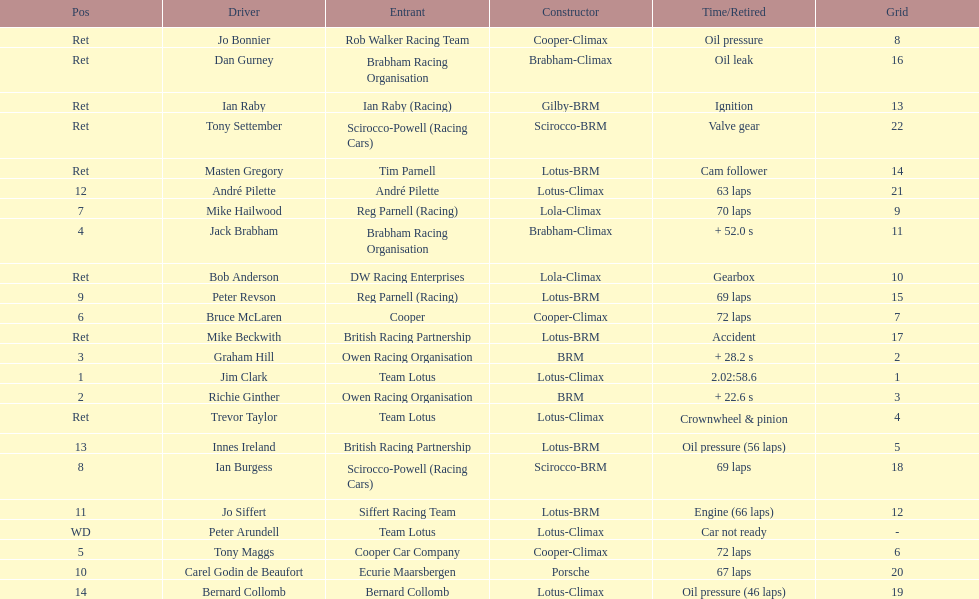What country had the least number of drivers, germany or the uk? Germany. 